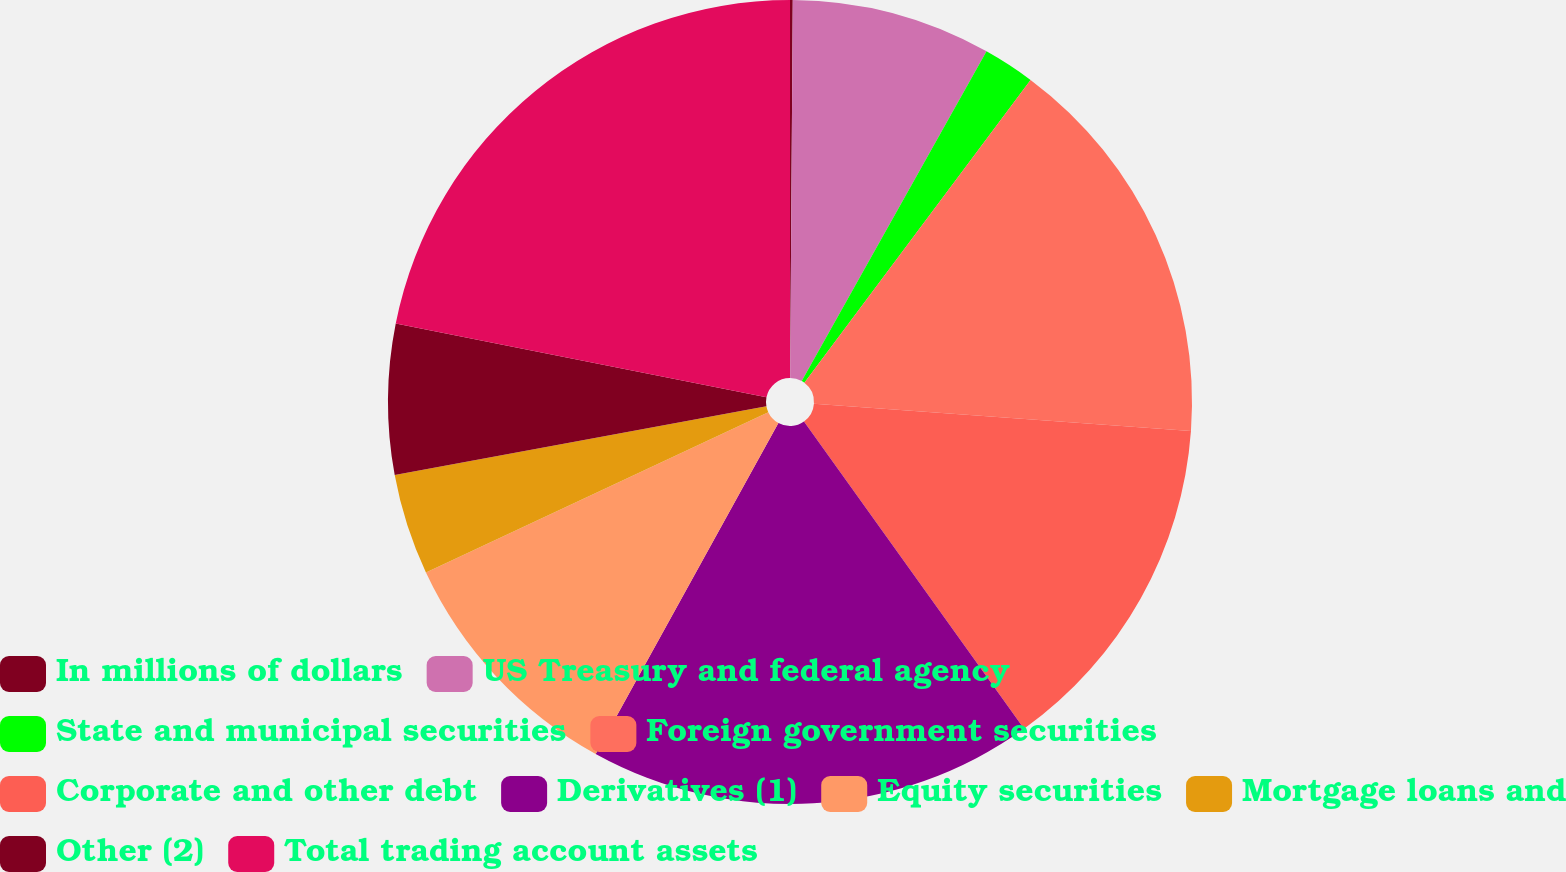Convert chart. <chart><loc_0><loc_0><loc_500><loc_500><pie_chart><fcel>In millions of dollars<fcel>US Treasury and federal agency<fcel>State and municipal securities<fcel>Foreign government securities<fcel>Corporate and other debt<fcel>Derivatives (1)<fcel>Equity securities<fcel>Mortgage loans and<fcel>Other (2)<fcel>Total trading account assets<nl><fcel>0.11%<fcel>8.02%<fcel>2.08%<fcel>15.94%<fcel>13.96%<fcel>17.92%<fcel>10.0%<fcel>4.06%<fcel>6.04%<fcel>21.87%<nl></chart> 